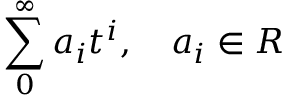Convert formula to latex. <formula><loc_0><loc_0><loc_500><loc_500>\sum _ { 0 } ^ { \infty } a _ { i } t ^ { i } , \quad a _ { i } \in R</formula> 